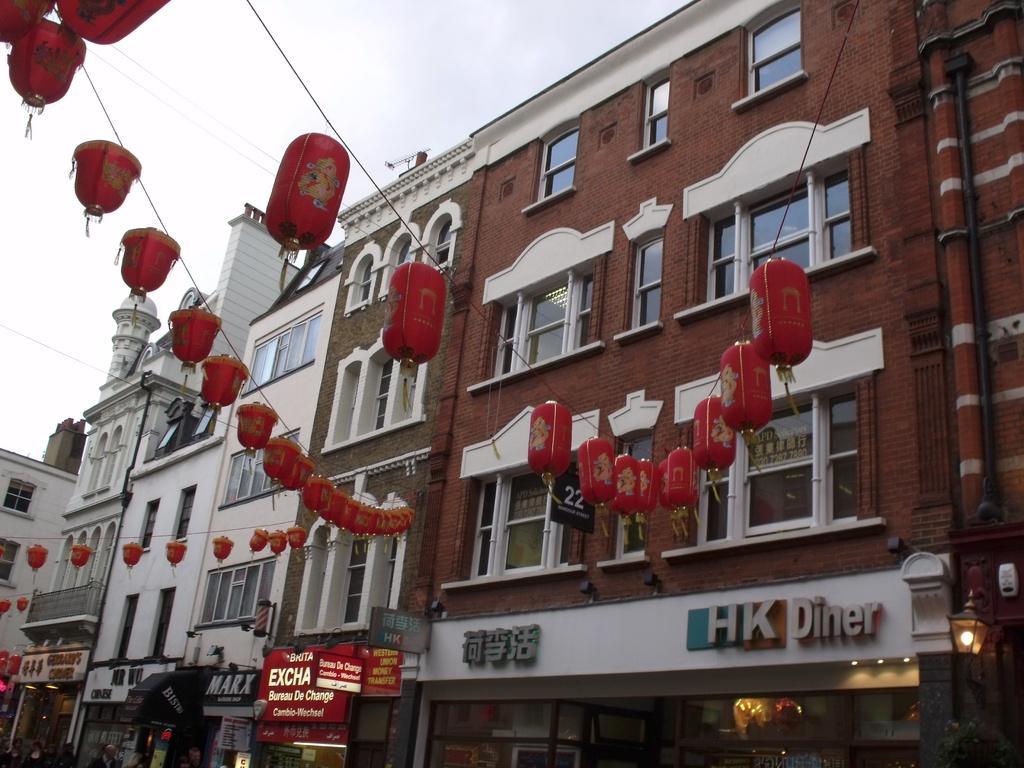Please provide a concise description of this image. In this picture we can see the lanterns, name boards, lights, pipes, buildings with windows and some objects and in the background we can see the sky. 